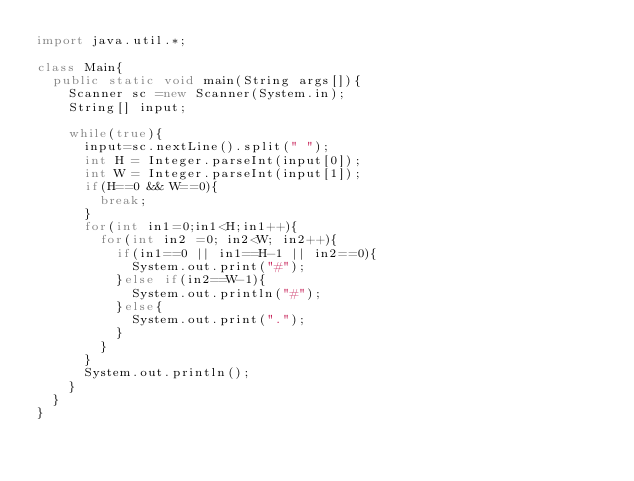<code> <loc_0><loc_0><loc_500><loc_500><_Java_>import java.util.*;

class Main{
	public static void main(String args[]){
		Scanner sc =new Scanner(System.in);
		String[] input;
		
		while(true){
			input=sc.nextLine().split(" ");
			int H = Integer.parseInt(input[0]);
			int W = Integer.parseInt(input[1]);
			if(H==0 && W==0){
				break;
			}
			for(int in1=0;in1<H;in1++){
				for(int in2 =0; in2<W; in2++){
					if(in1==0 || in1==H-1 || in2==0){
						System.out.print("#");
					}else if(in2==W-1){
						System.out.println("#");
					}else{
						System.out.print(".");
					}
				}
			}
			System.out.println();
		}
	}
}</code> 